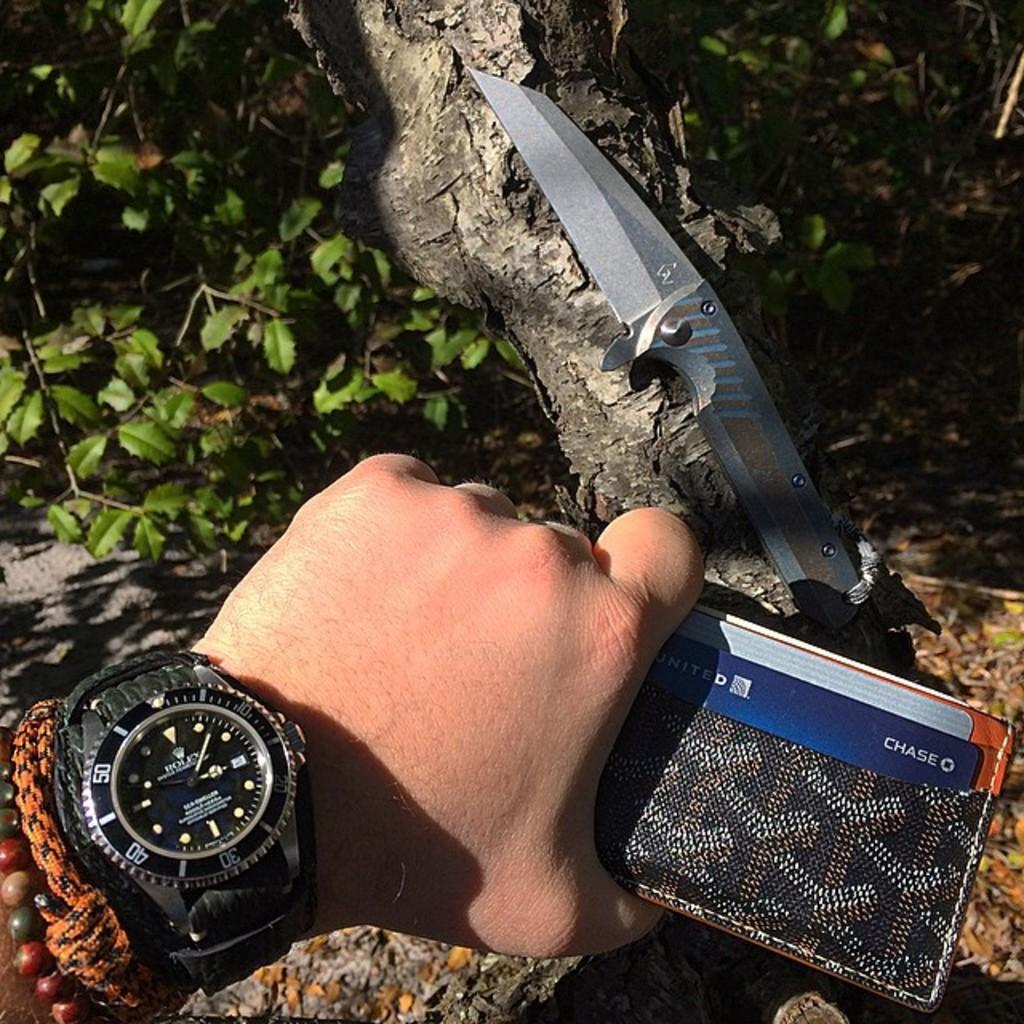<image>
Relay a brief, clear account of the picture shown. A hand holding a wallet and in the wallet is a card that says Chase. 